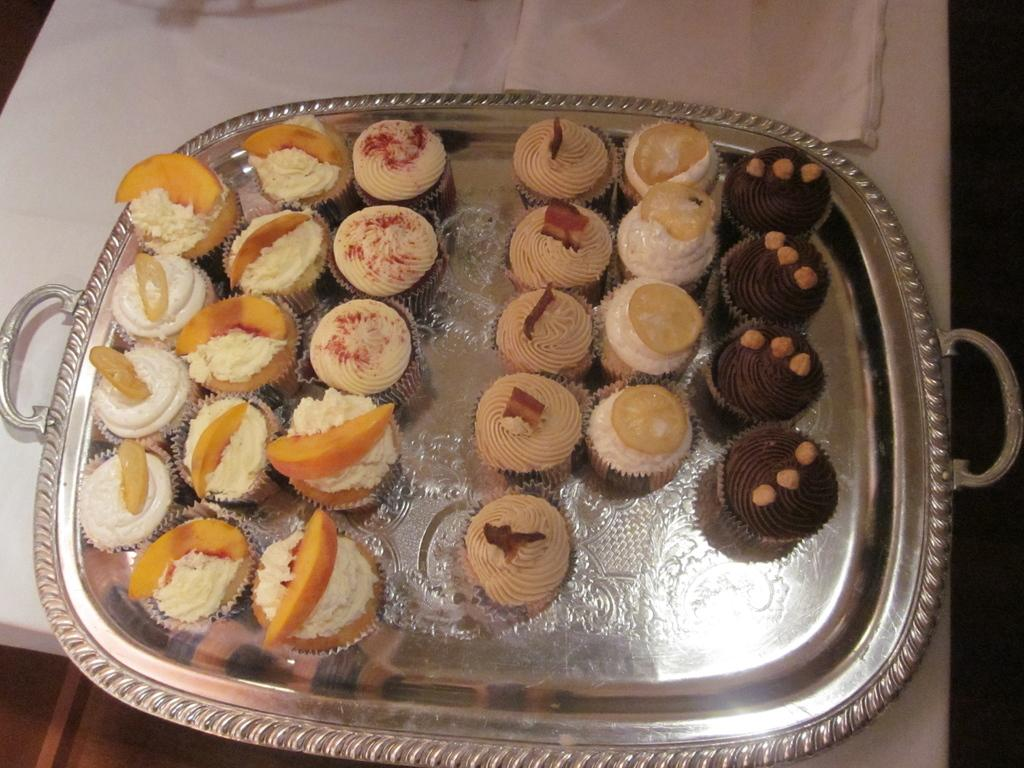What type of food is present in the image? There are cupcakes in the image. How are the cupcakes arranged in the image? The cupcakes are in a tray. What colors can be seen on the cupcakes? The cupcakes are in brown, white, and cream colors. What is the surface beneath the tray? The tray is on a white surface. Is there a hydrant visible in the image? No, there is no hydrant present in the image. Can you tell me how many people are swimming in the image? There is no swimming or people visible in the image; it only features cupcakes in a tray. 